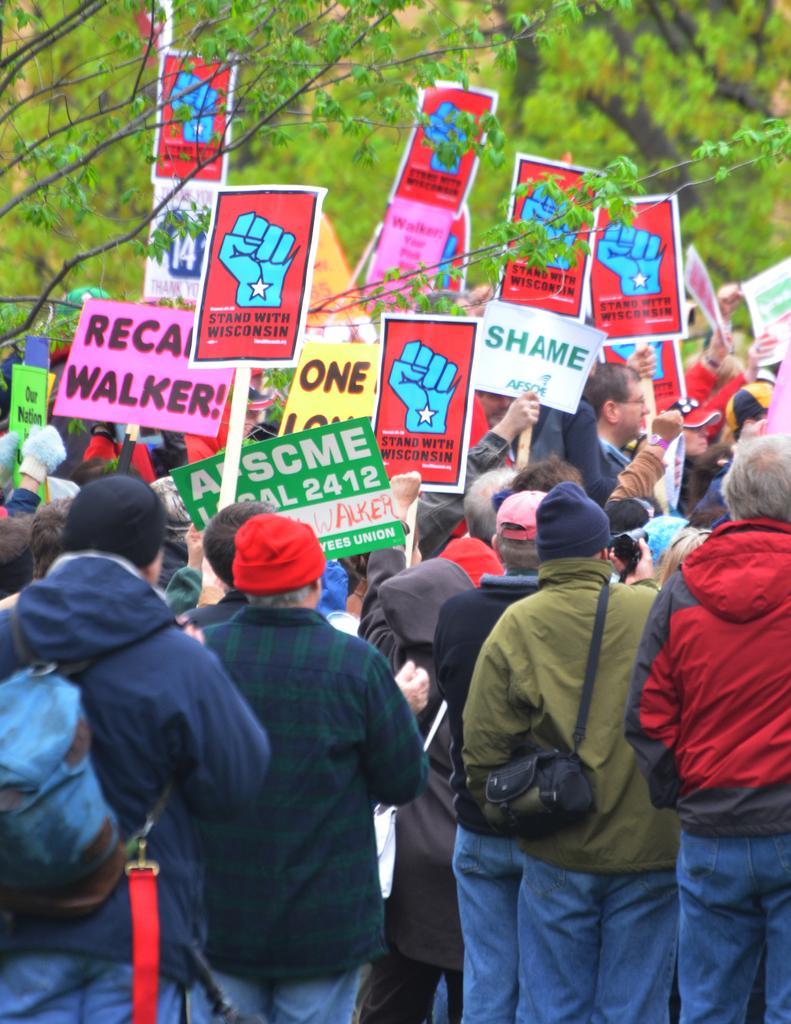Can you describe this image briefly? In the picture we can see a group of people are standing and holding a boards and doing strike and in the background we can see trees. 